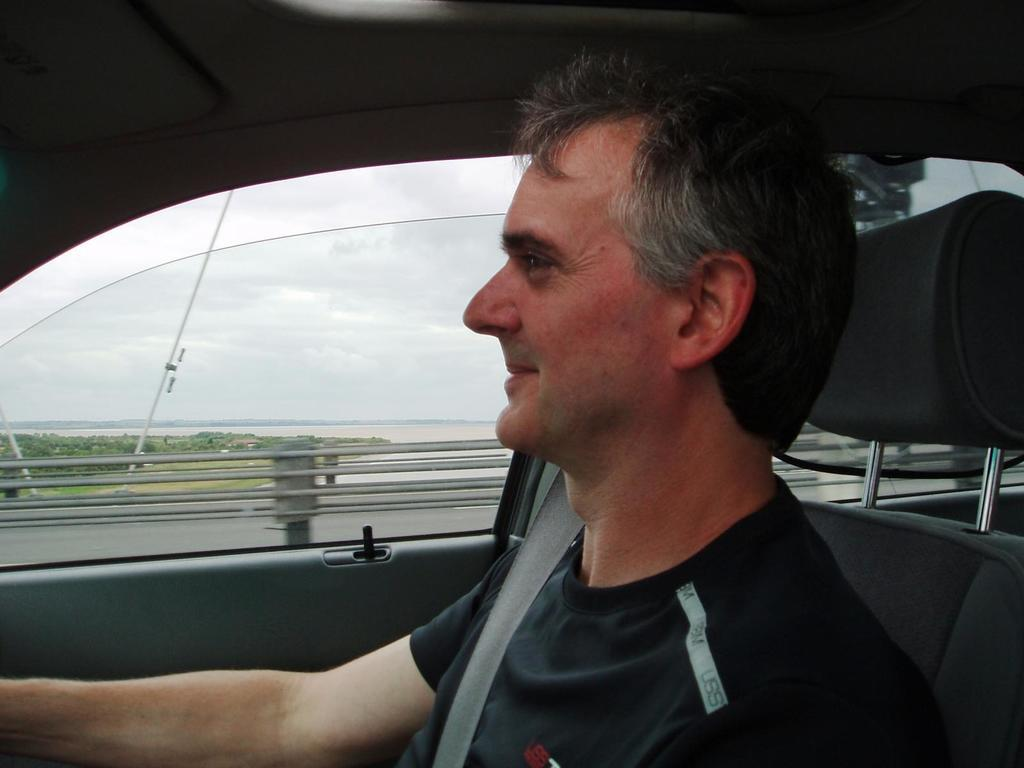What is the main subject of the image? There is a man inside a vehicle in the image. What can be seen in the background of the image? The sky is visible in the image. What book is the man reading while driving in the image? There is no book present in the image, and the man is not reading while driving. 